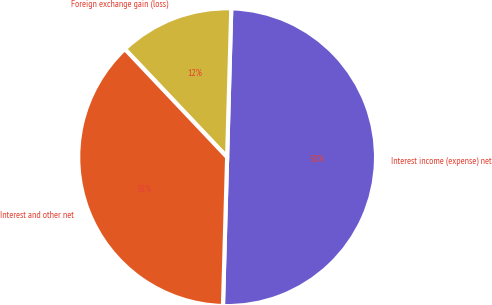Convert chart to OTSL. <chart><loc_0><loc_0><loc_500><loc_500><pie_chart><fcel>Interest income (expense) net<fcel>Foreign exchange gain (loss)<fcel>Interest and other net<nl><fcel>50.0%<fcel>12.5%<fcel>37.5%<nl></chart> 